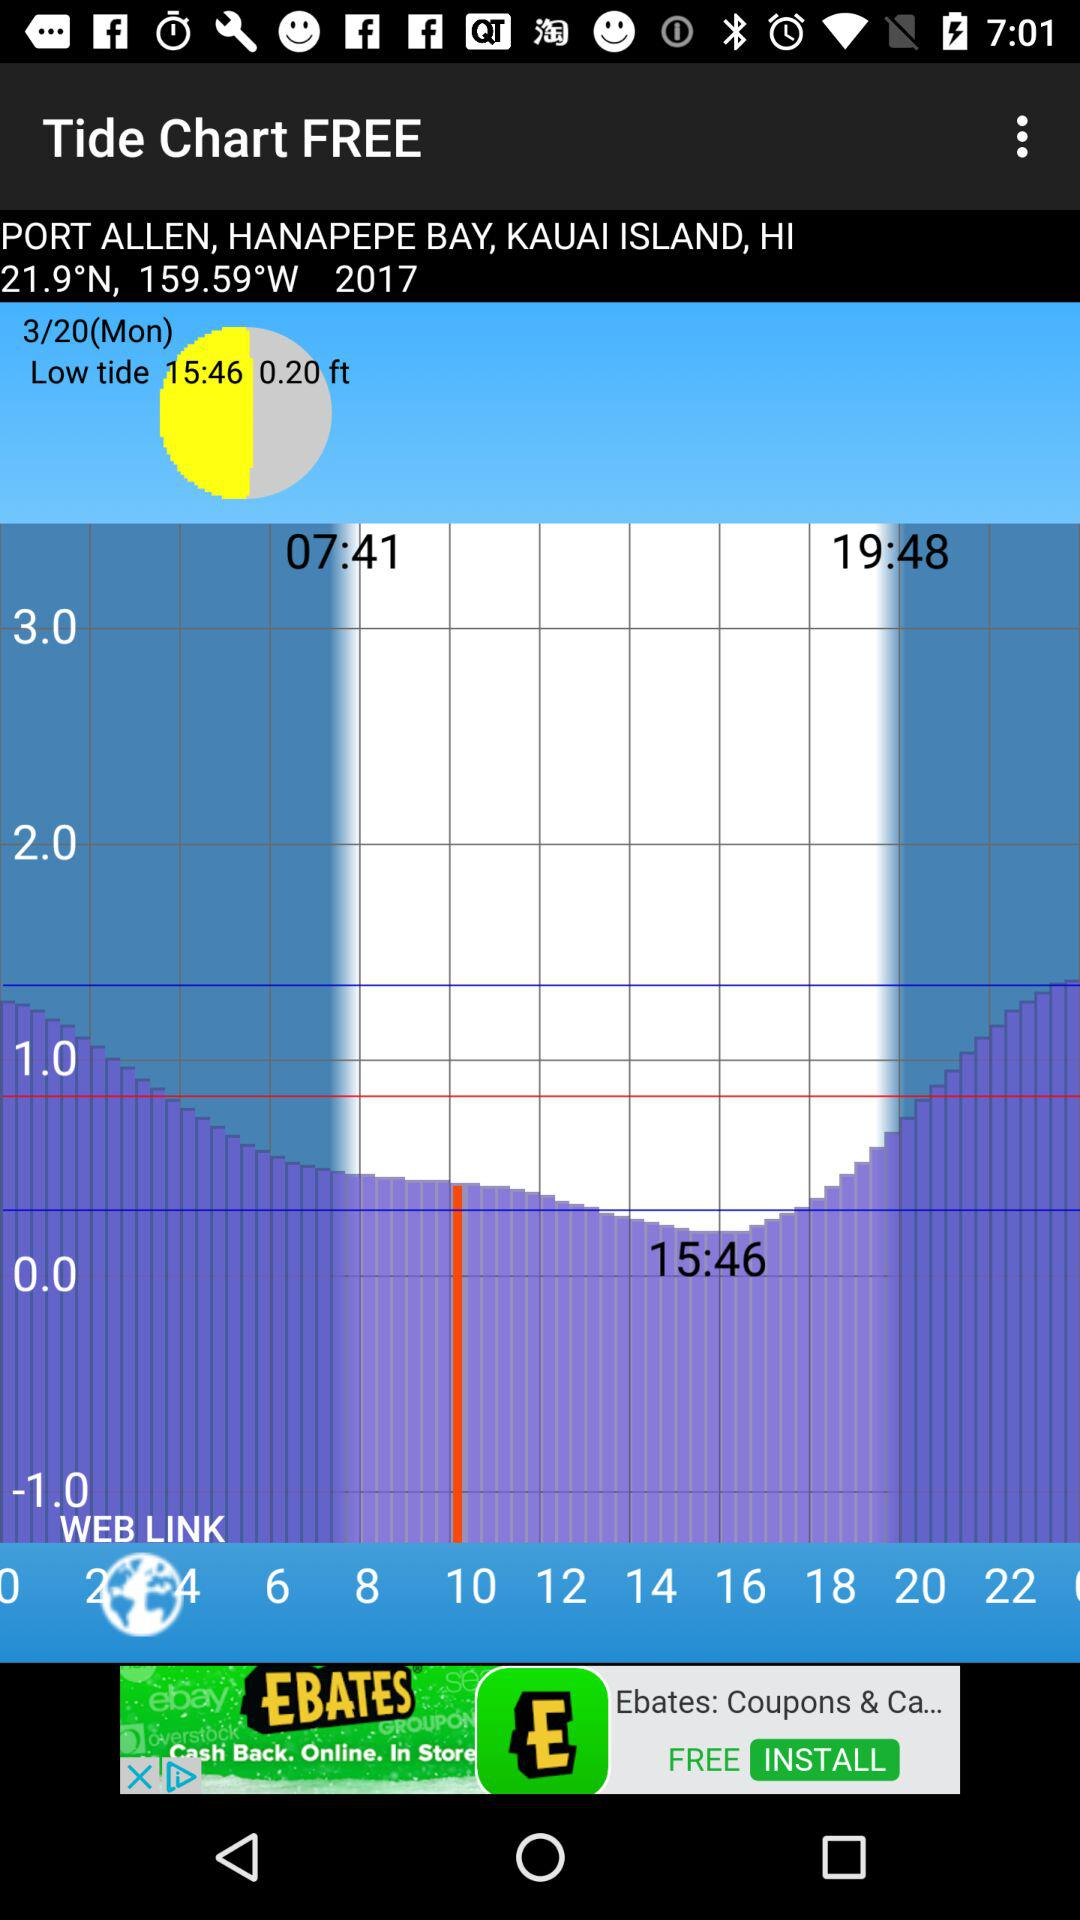What is the type of tide showing in the chart? The type of tide showing in the chart is low. 